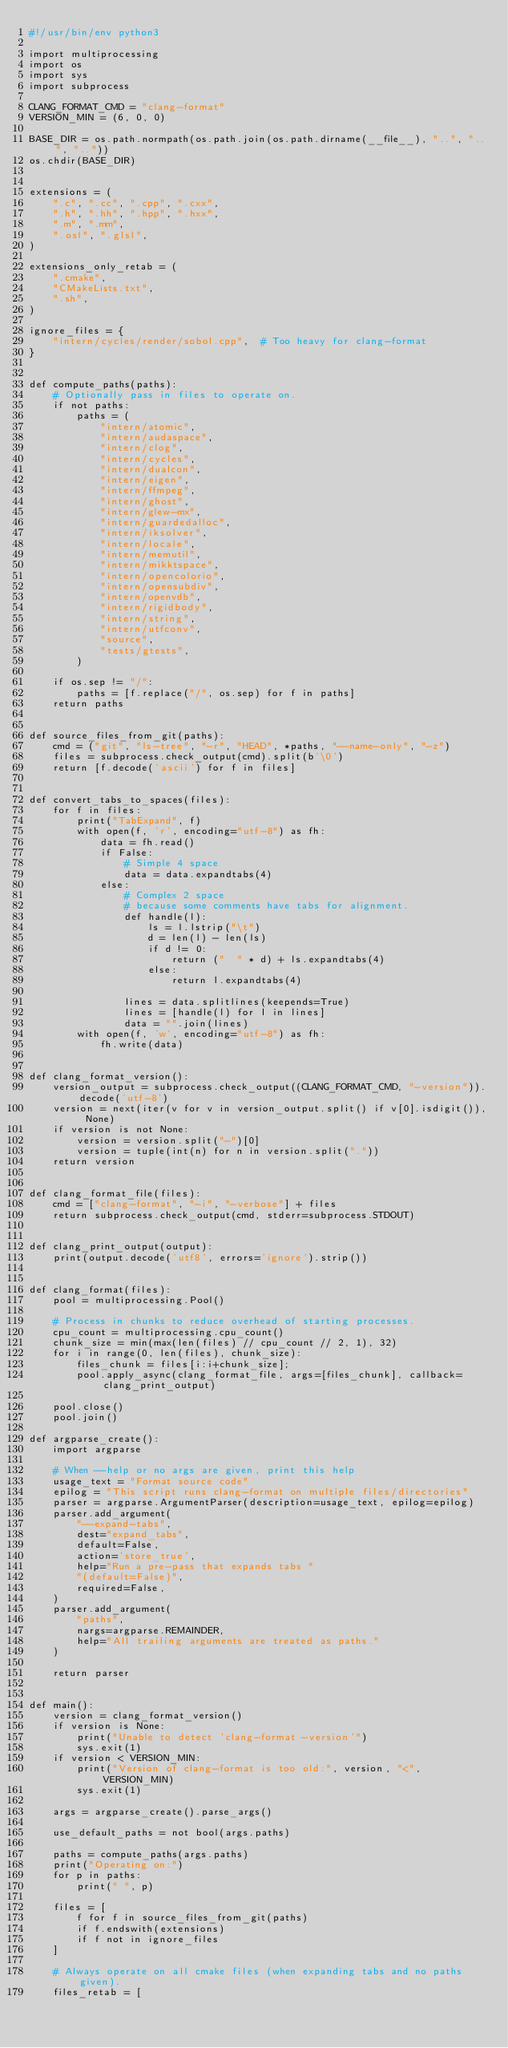<code> <loc_0><loc_0><loc_500><loc_500><_Python_>#!/usr/bin/env python3

import multiprocessing
import os
import sys
import subprocess

CLANG_FORMAT_CMD = "clang-format"
VERSION_MIN = (6, 0, 0)

BASE_DIR = os.path.normpath(os.path.join(os.path.dirname(__file__), "..", "..", ".."))
os.chdir(BASE_DIR)


extensions = (
    ".c", ".cc", ".cpp", ".cxx",
    ".h", ".hh", ".hpp", ".hxx",
    ".m", ".mm",
    ".osl", ".glsl",
)

extensions_only_retab = (
    ".cmake",
    "CMakeLists.txt",
    ".sh",
)

ignore_files = {
    "intern/cycles/render/sobol.cpp",  # Too heavy for clang-format
}


def compute_paths(paths):
    # Optionally pass in files to operate on.
    if not paths:
        paths = (
            "intern/atomic",
            "intern/audaspace",
            "intern/clog",
            "intern/cycles",
            "intern/dualcon",
            "intern/eigen",
            "intern/ffmpeg",
            "intern/ghost",
            "intern/glew-mx",
            "intern/guardedalloc",
            "intern/iksolver",
            "intern/locale",
            "intern/memutil",
            "intern/mikktspace",
            "intern/opencolorio",
            "intern/opensubdiv",
            "intern/openvdb",
            "intern/rigidbody",
            "intern/string",
            "intern/utfconv",
            "source",
            "tests/gtests",
        )

    if os.sep != "/":
        paths = [f.replace("/", os.sep) for f in paths]
    return paths


def source_files_from_git(paths):
    cmd = ("git", "ls-tree", "-r", "HEAD", *paths, "--name-only", "-z")
    files = subprocess.check_output(cmd).split(b'\0')
    return [f.decode('ascii') for f in files]


def convert_tabs_to_spaces(files):
    for f in files:
        print("TabExpand", f)
        with open(f, 'r', encoding="utf-8") as fh:
            data = fh.read()
            if False:
                # Simple 4 space
                data = data.expandtabs(4)
            else:
                # Complex 2 space
                # because some comments have tabs for alignment.
                def handle(l):
                    ls = l.lstrip("\t")
                    d = len(l) - len(ls)
                    if d != 0:
                        return ("  " * d) + ls.expandtabs(4)
                    else:
                        return l.expandtabs(4)

                lines = data.splitlines(keepends=True)
                lines = [handle(l) for l in lines]
                data = "".join(lines)
        with open(f, 'w', encoding="utf-8") as fh:
            fh.write(data)


def clang_format_version():
    version_output = subprocess.check_output((CLANG_FORMAT_CMD, "-version")).decode('utf-8')
    version = next(iter(v for v in version_output.split() if v[0].isdigit()), None)
    if version is not None:
        version = version.split("-")[0]
        version = tuple(int(n) for n in version.split("."))
    return version


def clang_format_file(files):
    cmd = ["clang-format", "-i", "-verbose"] + files
    return subprocess.check_output(cmd, stderr=subprocess.STDOUT)


def clang_print_output(output):
    print(output.decode('utf8', errors='ignore').strip())


def clang_format(files):
    pool = multiprocessing.Pool()

    # Process in chunks to reduce overhead of starting processes.
    cpu_count = multiprocessing.cpu_count()
    chunk_size = min(max(len(files) // cpu_count // 2, 1), 32)
    for i in range(0, len(files), chunk_size):
        files_chunk = files[i:i+chunk_size];
        pool.apply_async(clang_format_file, args=[files_chunk], callback=clang_print_output)

    pool.close()
    pool.join()

def argparse_create():
    import argparse

    # When --help or no args are given, print this help
    usage_text = "Format source code"
    epilog = "This script runs clang-format on multiple files/directories"
    parser = argparse.ArgumentParser(description=usage_text, epilog=epilog)
    parser.add_argument(
        "--expand-tabs",
        dest="expand_tabs",
        default=False,
        action='store_true',
        help="Run a pre-pass that expands tabs "
        "(default=False)",
        required=False,
    )
    parser.add_argument(
        "paths",
        nargs=argparse.REMAINDER,
        help="All trailing arguments are treated as paths."
    )

    return parser


def main():
    version = clang_format_version()
    if version is None:
        print("Unable to detect 'clang-format -version'")
        sys.exit(1)
    if version < VERSION_MIN:
        print("Version of clang-format is too old:", version, "<", VERSION_MIN)
        sys.exit(1)

    args = argparse_create().parse_args()

    use_default_paths = not bool(args.paths)

    paths = compute_paths(args.paths)
    print("Operating on:")
    for p in paths:
        print(" ", p)

    files = [
        f for f in source_files_from_git(paths)
        if f.endswith(extensions)
        if f not in ignore_files
    ]

    # Always operate on all cmake files (when expanding tabs and no paths given).
    files_retab = [</code> 